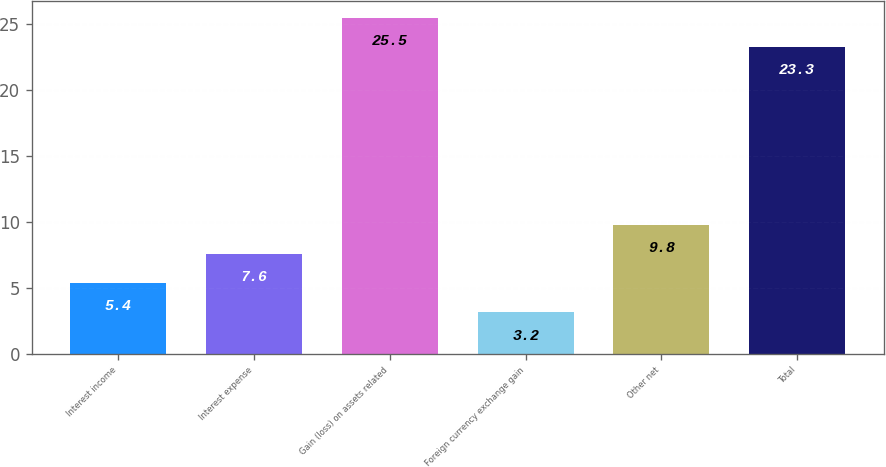<chart> <loc_0><loc_0><loc_500><loc_500><bar_chart><fcel>Interest income<fcel>Interest expense<fcel>Gain (loss) on assets related<fcel>Foreign currency exchange gain<fcel>Other net<fcel>Total<nl><fcel>5.4<fcel>7.6<fcel>25.5<fcel>3.2<fcel>9.8<fcel>23.3<nl></chart> 